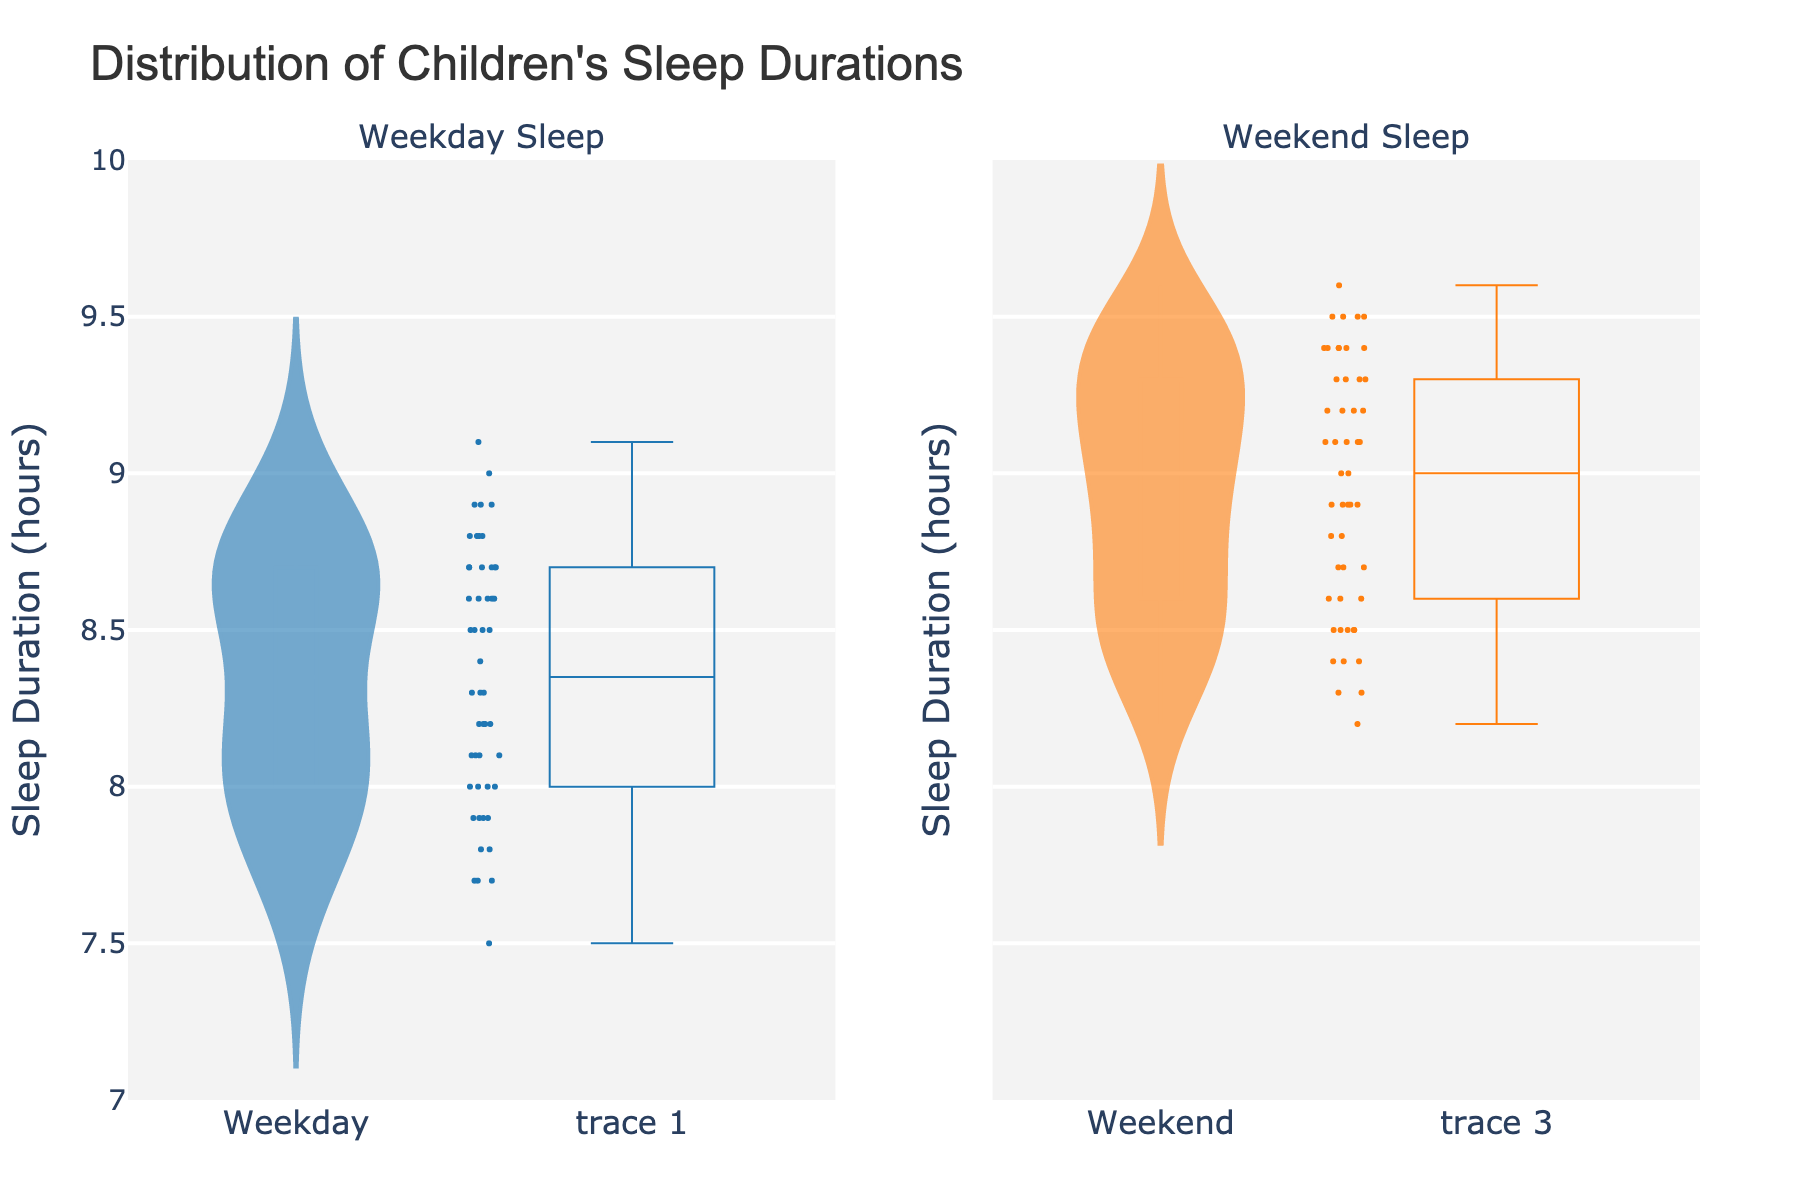What is the title of the chart? The title is displayed prominently at the top of the chart area. This is usually where the title of any chart is located. The title summarizes what the chart is about.
Answer: Distribution of Children's Sleep Durations How many subplots are present in the chart? Looking at the layout of the chart, there are two distinct subplots. Each subplot corresponds to different categories of data.
Answer: 2 Which day has a wider spread of sleep duration according to the chart, weekday or weekend? Observe the width of the violins and the spread of the data points for both weekdays and weekends. Wider plotted areas and more spread out data points usually indicate a wider spread.
Answer: Weekend What are the colors used for weekdays and weekends in the chart? Each subplot uses different colors to distinguish between weekdays and weekends. The colors are clearly visible in the violin plots and jittered points.
Answer: Weekdays: Blue, Weekends: Orange What is the median sleep duration for children on weekends? The median can be seen where the white dash is placed inside the violin plot for weekends. This is where the center line of the box plot would be located within the violin.
Answer: Approximately 9.1 hours On which day do children generally sleep longer on average, weekdays or weekends? Compare the central tendency (median) of the two violin plots. Generally, the higher median indicates longer sleep duration on average.
Answer: Weekends What is the range of sleep durations on weekdays? The range can be assessed by looking at the top and bottom edges of the violin plot for weekdays. The maximum and minimum values within the plot provide the range.
Answer: 7.5 to 9.1 hours Which subplot has more uniform distribution of sleep durations? A more uniform distribution will have a more symmetric, evenly spread violin plot without sharp peaks or overly concentrated regions. Look at the shapes of the violin plots for both subplots.
Answer: Weekdays What does the width of the violin plot represent in the context of this data? The width of the violin plot at different values represents the density of data points around those values. Wider sections indicate regions where more data points are concentrated.
Answer: Density of sleep durations How do the sleep durations on weekdays compare with weekends in terms of variability? Variability can be assessed by observing the spread and width of the data points along the y-axis in each violin plot. A more variable dataset will have a wider spread.
Answer: Weekends show greater variability 